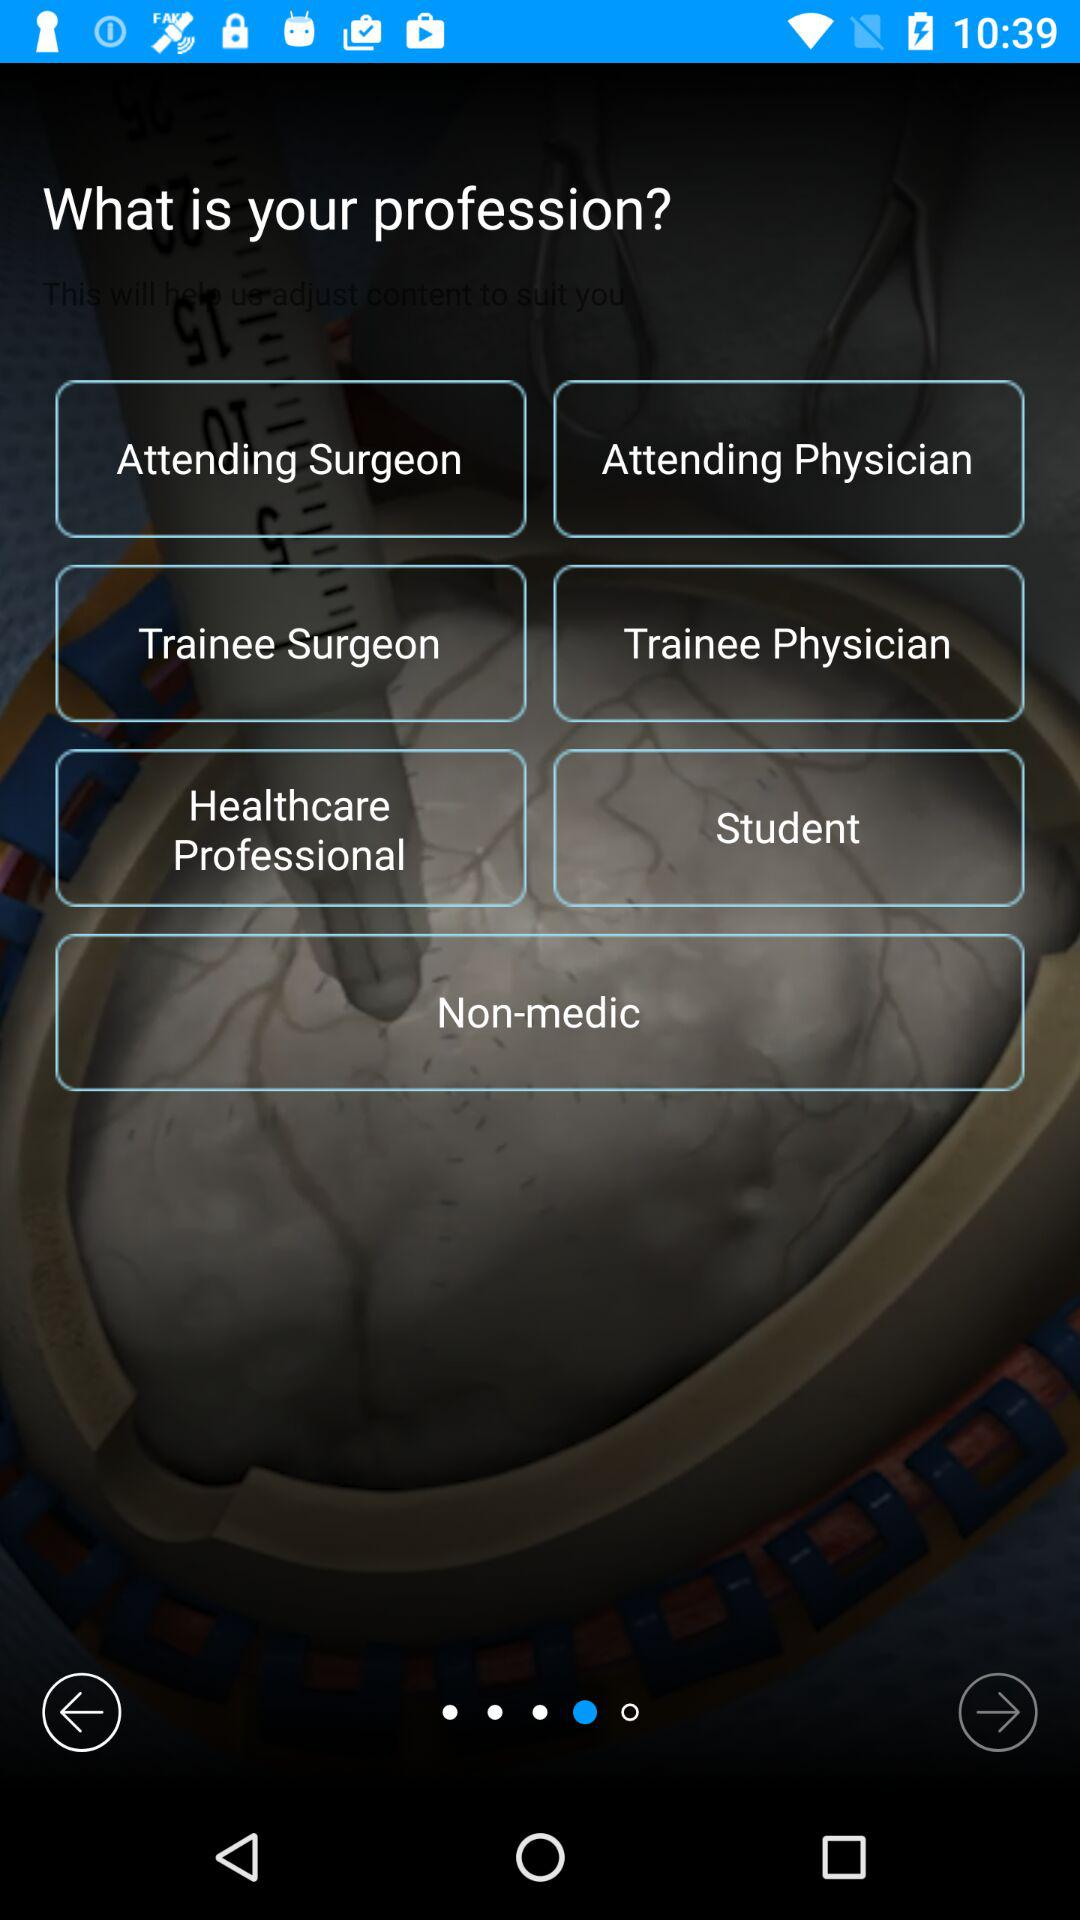What are the given names of the different professions? The given names of the different professions are attending surgeon, attending physician, trainee surgeon, trainee physician, healthcare professional, student and non-medic. 